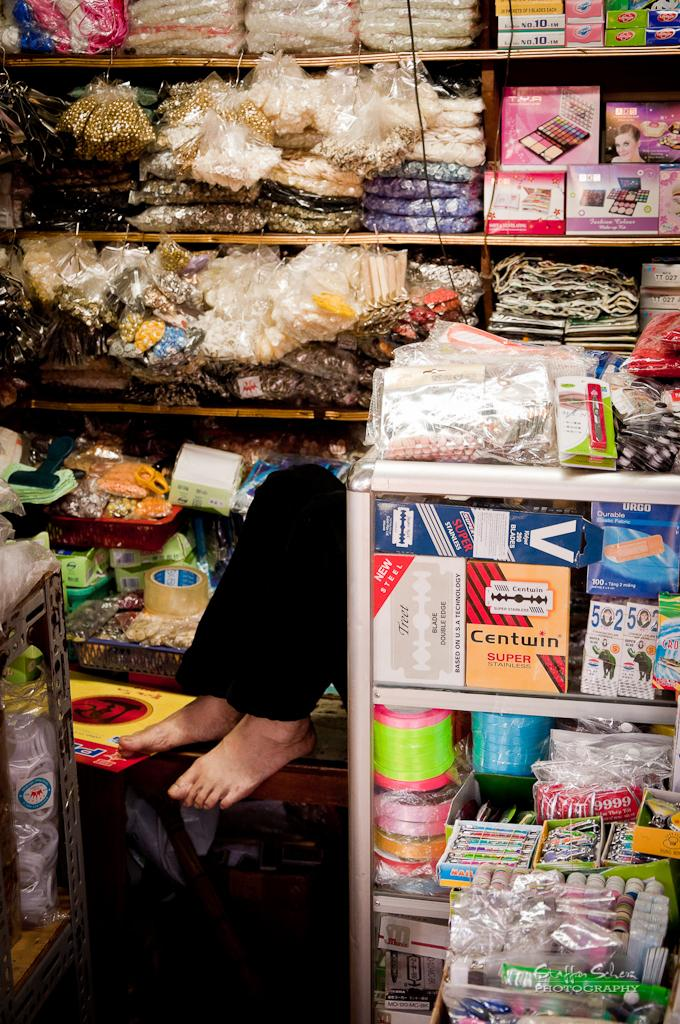<image>
Share a concise interpretation of the image provided. Amongst all the items on the shelves, lies a box of Centwin brand razors. 